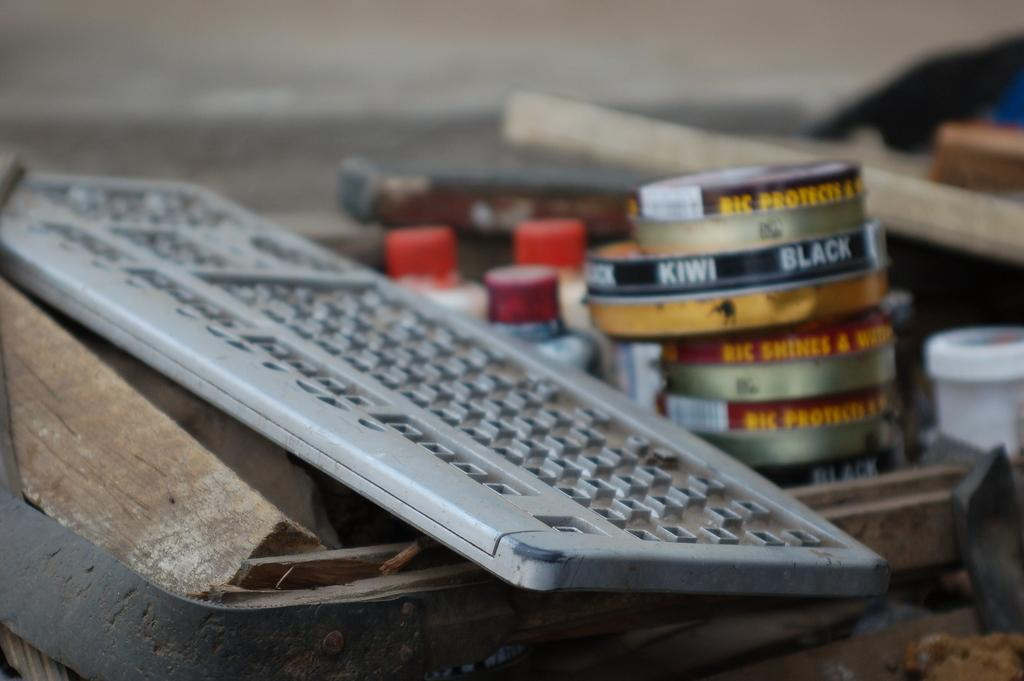Provide a one-sentence caption for the provided image. An old keyboard is stacked on a create next to Kiwi Black shoe polish. 